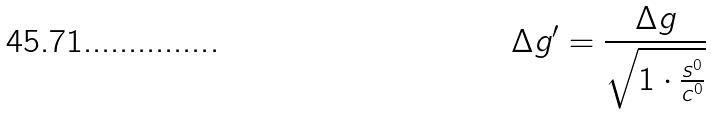Convert formula to latex. <formula><loc_0><loc_0><loc_500><loc_500>\Delta g ^ { \prime } = \frac { \Delta g } { \sqrt { 1 \cdot \frac { s ^ { 0 } } { c ^ { 0 } } } }</formula> 